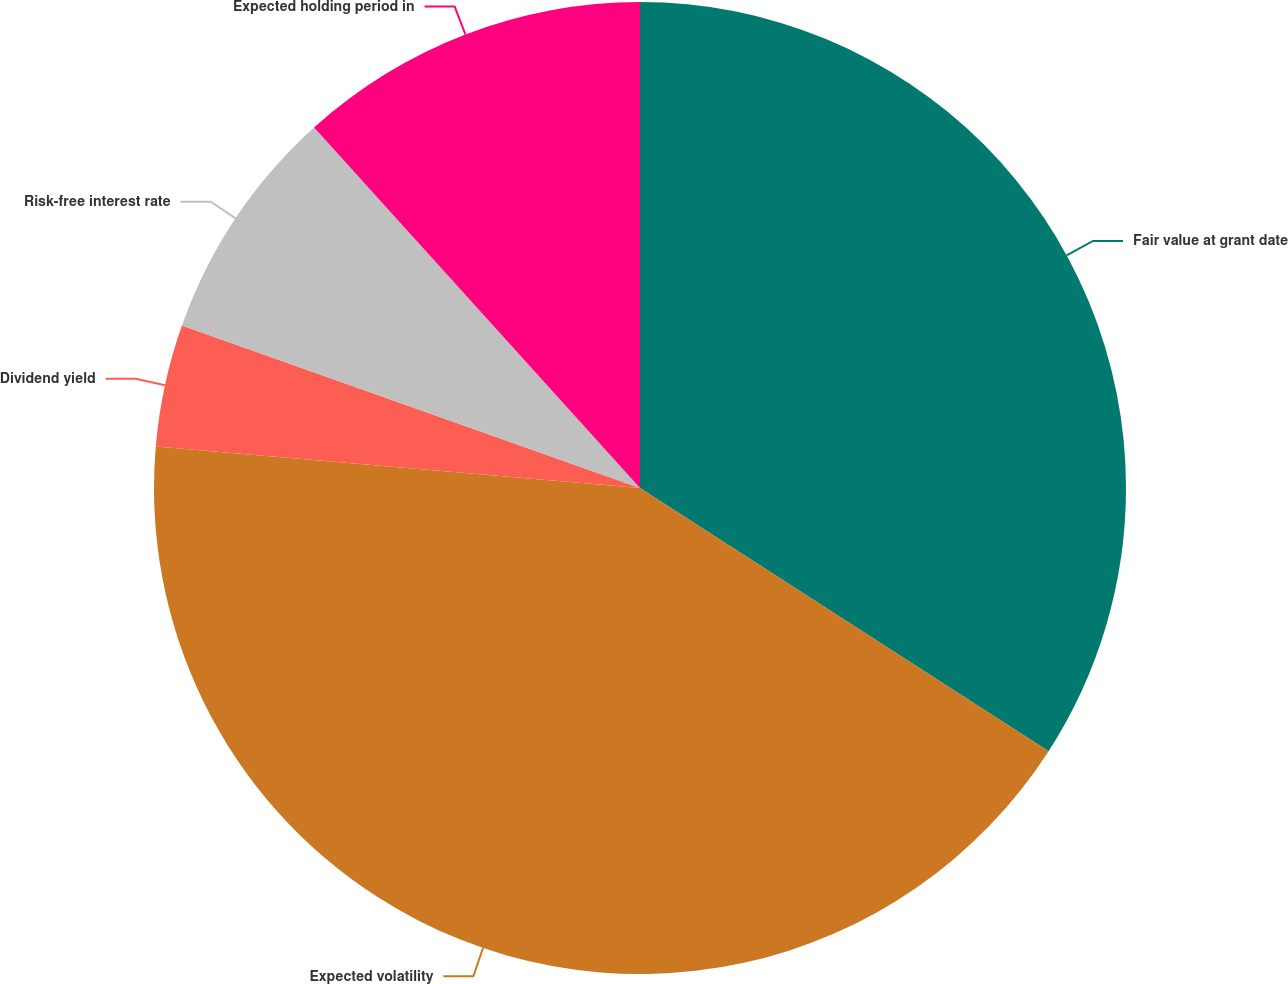<chart> <loc_0><loc_0><loc_500><loc_500><pie_chart><fcel>Fair value at grant date<fcel>Expected volatility<fcel>Dividend yield<fcel>Risk-free interest rate<fcel>Expected holding period in<nl><fcel>34.11%<fcel>42.26%<fcel>4.06%<fcel>7.88%<fcel>11.7%<nl></chart> 